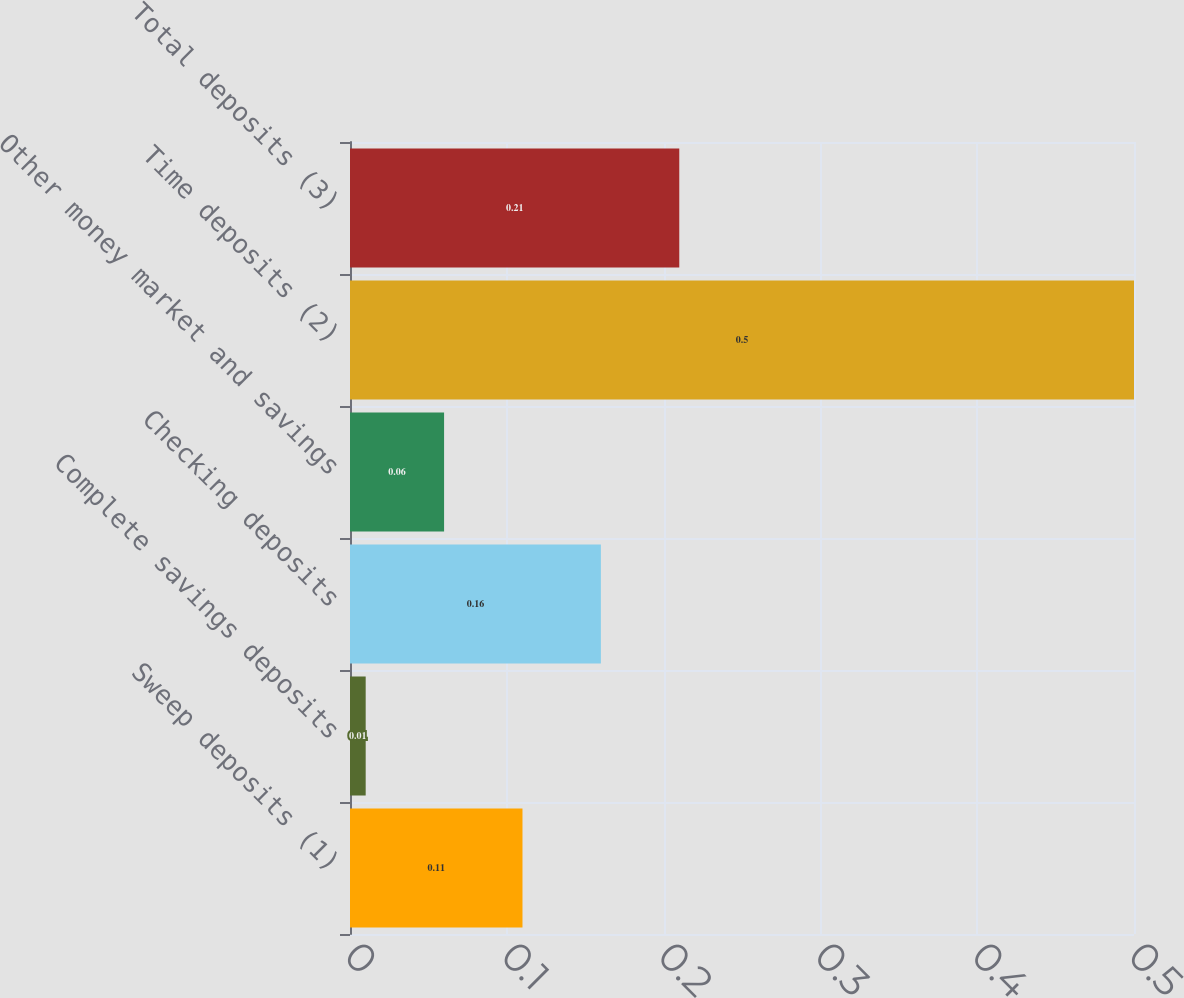Convert chart. <chart><loc_0><loc_0><loc_500><loc_500><bar_chart><fcel>Sweep deposits (1)<fcel>Complete savings deposits<fcel>Checking deposits<fcel>Other money market and savings<fcel>Time deposits (2)<fcel>Total deposits (3)<nl><fcel>0.11<fcel>0.01<fcel>0.16<fcel>0.06<fcel>0.5<fcel>0.21<nl></chart> 